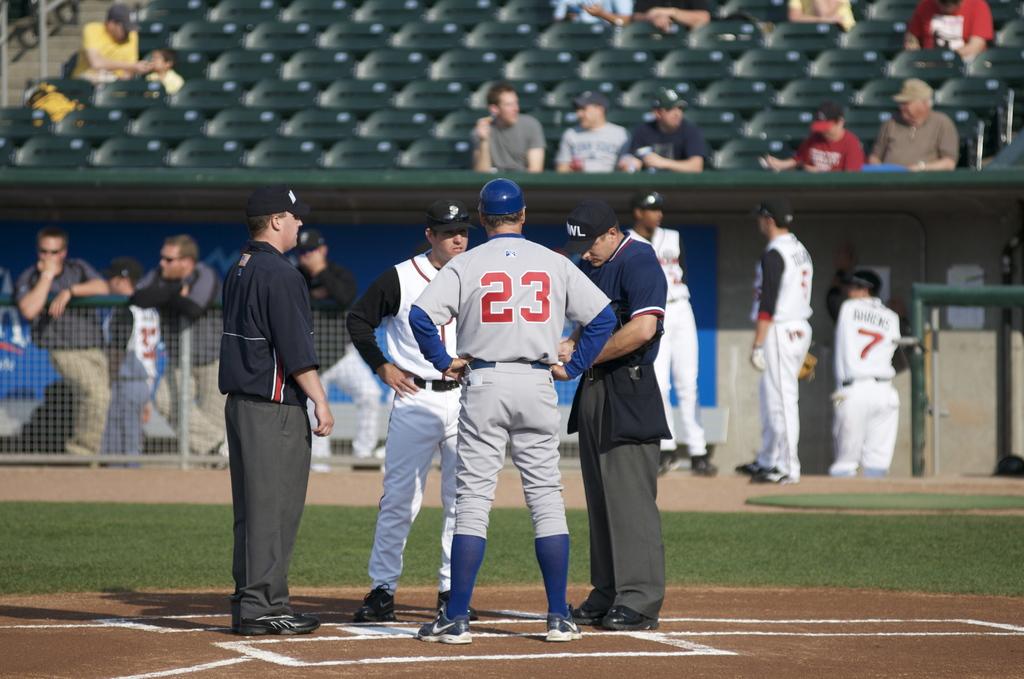What number is the player?
Offer a terse response. 23. What is the number of the player in the dugout with his back to us?
Provide a succinct answer. 7. 